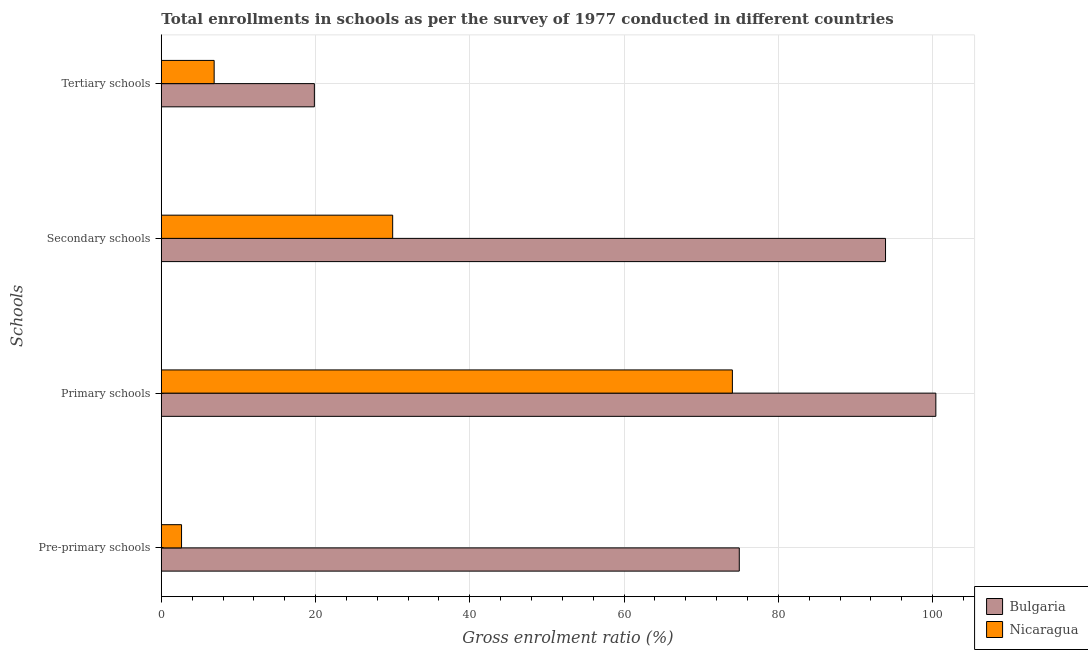How many different coloured bars are there?
Give a very brief answer. 2. Are the number of bars per tick equal to the number of legend labels?
Provide a short and direct response. Yes. How many bars are there on the 2nd tick from the bottom?
Your answer should be compact. 2. What is the label of the 4th group of bars from the top?
Provide a succinct answer. Pre-primary schools. What is the gross enrolment ratio in tertiary schools in Nicaragua?
Make the answer very short. 6.85. Across all countries, what is the maximum gross enrolment ratio in primary schools?
Provide a succinct answer. 100.42. Across all countries, what is the minimum gross enrolment ratio in secondary schools?
Give a very brief answer. 30. In which country was the gross enrolment ratio in pre-primary schools maximum?
Offer a very short reply. Bulgaria. In which country was the gross enrolment ratio in secondary schools minimum?
Offer a terse response. Nicaragua. What is the total gross enrolment ratio in secondary schools in the graph?
Your answer should be compact. 123.89. What is the difference between the gross enrolment ratio in primary schools in Bulgaria and that in Nicaragua?
Provide a succinct answer. 26.38. What is the difference between the gross enrolment ratio in primary schools in Nicaragua and the gross enrolment ratio in secondary schools in Bulgaria?
Your response must be concise. -19.85. What is the average gross enrolment ratio in pre-primary schools per country?
Ensure brevity in your answer.  38.78. What is the difference between the gross enrolment ratio in tertiary schools and gross enrolment ratio in secondary schools in Nicaragua?
Your answer should be very brief. -23.14. In how many countries, is the gross enrolment ratio in pre-primary schools greater than 28 %?
Offer a terse response. 1. What is the ratio of the gross enrolment ratio in secondary schools in Bulgaria to that in Nicaragua?
Provide a succinct answer. 3.13. Is the difference between the gross enrolment ratio in secondary schools in Nicaragua and Bulgaria greater than the difference between the gross enrolment ratio in primary schools in Nicaragua and Bulgaria?
Give a very brief answer. No. What is the difference between the highest and the second highest gross enrolment ratio in tertiary schools?
Your answer should be very brief. 12.99. What is the difference between the highest and the lowest gross enrolment ratio in tertiary schools?
Ensure brevity in your answer.  12.99. Is the sum of the gross enrolment ratio in secondary schools in Bulgaria and Nicaragua greater than the maximum gross enrolment ratio in pre-primary schools across all countries?
Ensure brevity in your answer.  Yes. Is it the case that in every country, the sum of the gross enrolment ratio in primary schools and gross enrolment ratio in tertiary schools is greater than the sum of gross enrolment ratio in secondary schools and gross enrolment ratio in pre-primary schools?
Ensure brevity in your answer.  No. What does the 2nd bar from the top in Secondary schools represents?
Your response must be concise. Bulgaria. What is the difference between two consecutive major ticks on the X-axis?
Keep it short and to the point. 20. Are the values on the major ticks of X-axis written in scientific E-notation?
Ensure brevity in your answer.  No. How are the legend labels stacked?
Your answer should be compact. Vertical. What is the title of the graph?
Your answer should be compact. Total enrollments in schools as per the survey of 1977 conducted in different countries. Does "Least developed countries" appear as one of the legend labels in the graph?
Provide a succinct answer. No. What is the label or title of the X-axis?
Make the answer very short. Gross enrolment ratio (%). What is the label or title of the Y-axis?
Provide a succinct answer. Schools. What is the Gross enrolment ratio (%) in Bulgaria in Pre-primary schools?
Keep it short and to the point. 74.94. What is the Gross enrolment ratio (%) of Nicaragua in Pre-primary schools?
Offer a very short reply. 2.62. What is the Gross enrolment ratio (%) in Bulgaria in Primary schools?
Make the answer very short. 100.42. What is the Gross enrolment ratio (%) of Nicaragua in Primary schools?
Provide a short and direct response. 74.04. What is the Gross enrolment ratio (%) of Bulgaria in Secondary schools?
Offer a very short reply. 93.9. What is the Gross enrolment ratio (%) of Nicaragua in Secondary schools?
Give a very brief answer. 30. What is the Gross enrolment ratio (%) of Bulgaria in Tertiary schools?
Your response must be concise. 19.84. What is the Gross enrolment ratio (%) in Nicaragua in Tertiary schools?
Your response must be concise. 6.85. Across all Schools, what is the maximum Gross enrolment ratio (%) in Bulgaria?
Give a very brief answer. 100.42. Across all Schools, what is the maximum Gross enrolment ratio (%) in Nicaragua?
Ensure brevity in your answer.  74.04. Across all Schools, what is the minimum Gross enrolment ratio (%) in Bulgaria?
Give a very brief answer. 19.84. Across all Schools, what is the minimum Gross enrolment ratio (%) in Nicaragua?
Offer a very short reply. 2.62. What is the total Gross enrolment ratio (%) of Bulgaria in the graph?
Keep it short and to the point. 289.1. What is the total Gross enrolment ratio (%) of Nicaragua in the graph?
Provide a succinct answer. 113.51. What is the difference between the Gross enrolment ratio (%) in Bulgaria in Pre-primary schools and that in Primary schools?
Provide a short and direct response. -25.48. What is the difference between the Gross enrolment ratio (%) of Nicaragua in Pre-primary schools and that in Primary schools?
Provide a succinct answer. -71.42. What is the difference between the Gross enrolment ratio (%) of Bulgaria in Pre-primary schools and that in Secondary schools?
Offer a very short reply. -18.96. What is the difference between the Gross enrolment ratio (%) of Nicaragua in Pre-primary schools and that in Secondary schools?
Your answer should be very brief. -27.37. What is the difference between the Gross enrolment ratio (%) in Bulgaria in Pre-primary schools and that in Tertiary schools?
Ensure brevity in your answer.  55.09. What is the difference between the Gross enrolment ratio (%) of Nicaragua in Pre-primary schools and that in Tertiary schools?
Give a very brief answer. -4.23. What is the difference between the Gross enrolment ratio (%) of Bulgaria in Primary schools and that in Secondary schools?
Your answer should be very brief. 6.52. What is the difference between the Gross enrolment ratio (%) of Nicaragua in Primary schools and that in Secondary schools?
Offer a very short reply. 44.05. What is the difference between the Gross enrolment ratio (%) of Bulgaria in Primary schools and that in Tertiary schools?
Offer a very short reply. 80.58. What is the difference between the Gross enrolment ratio (%) of Nicaragua in Primary schools and that in Tertiary schools?
Make the answer very short. 67.19. What is the difference between the Gross enrolment ratio (%) of Bulgaria in Secondary schools and that in Tertiary schools?
Provide a succinct answer. 74.05. What is the difference between the Gross enrolment ratio (%) of Nicaragua in Secondary schools and that in Tertiary schools?
Give a very brief answer. 23.14. What is the difference between the Gross enrolment ratio (%) in Bulgaria in Pre-primary schools and the Gross enrolment ratio (%) in Nicaragua in Primary schools?
Keep it short and to the point. 0.89. What is the difference between the Gross enrolment ratio (%) of Bulgaria in Pre-primary schools and the Gross enrolment ratio (%) of Nicaragua in Secondary schools?
Offer a terse response. 44.94. What is the difference between the Gross enrolment ratio (%) in Bulgaria in Pre-primary schools and the Gross enrolment ratio (%) in Nicaragua in Tertiary schools?
Your response must be concise. 68.08. What is the difference between the Gross enrolment ratio (%) of Bulgaria in Primary schools and the Gross enrolment ratio (%) of Nicaragua in Secondary schools?
Make the answer very short. 70.42. What is the difference between the Gross enrolment ratio (%) in Bulgaria in Primary schools and the Gross enrolment ratio (%) in Nicaragua in Tertiary schools?
Your response must be concise. 93.57. What is the difference between the Gross enrolment ratio (%) in Bulgaria in Secondary schools and the Gross enrolment ratio (%) in Nicaragua in Tertiary schools?
Ensure brevity in your answer.  87.05. What is the average Gross enrolment ratio (%) in Bulgaria per Schools?
Keep it short and to the point. 72.27. What is the average Gross enrolment ratio (%) in Nicaragua per Schools?
Provide a short and direct response. 28.38. What is the difference between the Gross enrolment ratio (%) in Bulgaria and Gross enrolment ratio (%) in Nicaragua in Pre-primary schools?
Keep it short and to the point. 72.31. What is the difference between the Gross enrolment ratio (%) in Bulgaria and Gross enrolment ratio (%) in Nicaragua in Primary schools?
Ensure brevity in your answer.  26.38. What is the difference between the Gross enrolment ratio (%) in Bulgaria and Gross enrolment ratio (%) in Nicaragua in Secondary schools?
Provide a short and direct response. 63.9. What is the difference between the Gross enrolment ratio (%) of Bulgaria and Gross enrolment ratio (%) of Nicaragua in Tertiary schools?
Offer a very short reply. 12.99. What is the ratio of the Gross enrolment ratio (%) of Bulgaria in Pre-primary schools to that in Primary schools?
Offer a terse response. 0.75. What is the ratio of the Gross enrolment ratio (%) of Nicaragua in Pre-primary schools to that in Primary schools?
Offer a very short reply. 0.04. What is the ratio of the Gross enrolment ratio (%) of Bulgaria in Pre-primary schools to that in Secondary schools?
Keep it short and to the point. 0.8. What is the ratio of the Gross enrolment ratio (%) in Nicaragua in Pre-primary schools to that in Secondary schools?
Your response must be concise. 0.09. What is the ratio of the Gross enrolment ratio (%) in Bulgaria in Pre-primary schools to that in Tertiary schools?
Offer a terse response. 3.78. What is the ratio of the Gross enrolment ratio (%) in Nicaragua in Pre-primary schools to that in Tertiary schools?
Provide a short and direct response. 0.38. What is the ratio of the Gross enrolment ratio (%) of Bulgaria in Primary schools to that in Secondary schools?
Offer a very short reply. 1.07. What is the ratio of the Gross enrolment ratio (%) of Nicaragua in Primary schools to that in Secondary schools?
Offer a very short reply. 2.47. What is the ratio of the Gross enrolment ratio (%) in Bulgaria in Primary schools to that in Tertiary schools?
Make the answer very short. 5.06. What is the ratio of the Gross enrolment ratio (%) in Nicaragua in Primary schools to that in Tertiary schools?
Provide a short and direct response. 10.81. What is the ratio of the Gross enrolment ratio (%) of Bulgaria in Secondary schools to that in Tertiary schools?
Your response must be concise. 4.73. What is the ratio of the Gross enrolment ratio (%) in Nicaragua in Secondary schools to that in Tertiary schools?
Ensure brevity in your answer.  4.38. What is the difference between the highest and the second highest Gross enrolment ratio (%) in Bulgaria?
Your response must be concise. 6.52. What is the difference between the highest and the second highest Gross enrolment ratio (%) of Nicaragua?
Keep it short and to the point. 44.05. What is the difference between the highest and the lowest Gross enrolment ratio (%) of Bulgaria?
Your response must be concise. 80.58. What is the difference between the highest and the lowest Gross enrolment ratio (%) of Nicaragua?
Provide a succinct answer. 71.42. 